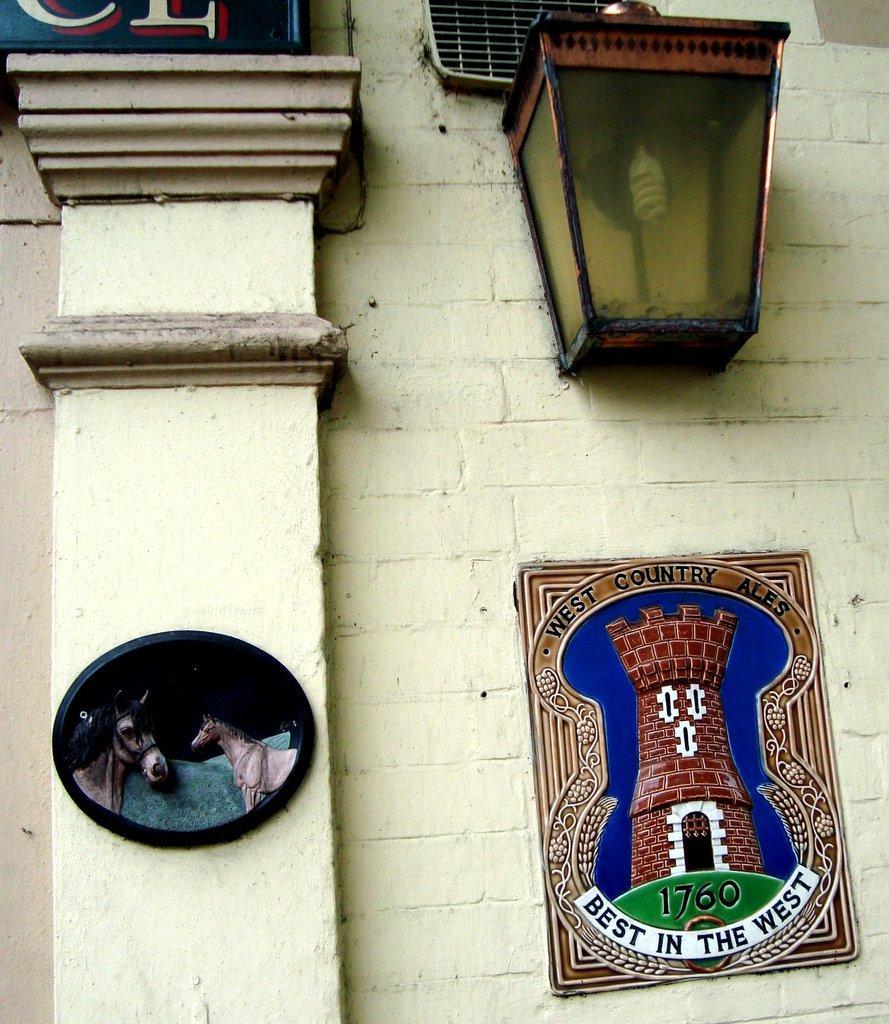In one or two sentences, can you explain what this image depicts? In the image there is a photo on the wall with a lamp above it, on the left side there is a pillar with photo of horse on it. 